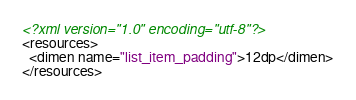<code> <loc_0><loc_0><loc_500><loc_500><_XML_><?xml version="1.0" encoding="utf-8"?>
<resources>
  <dimen name="list_item_padding">12dp</dimen>
</resources>
</code> 